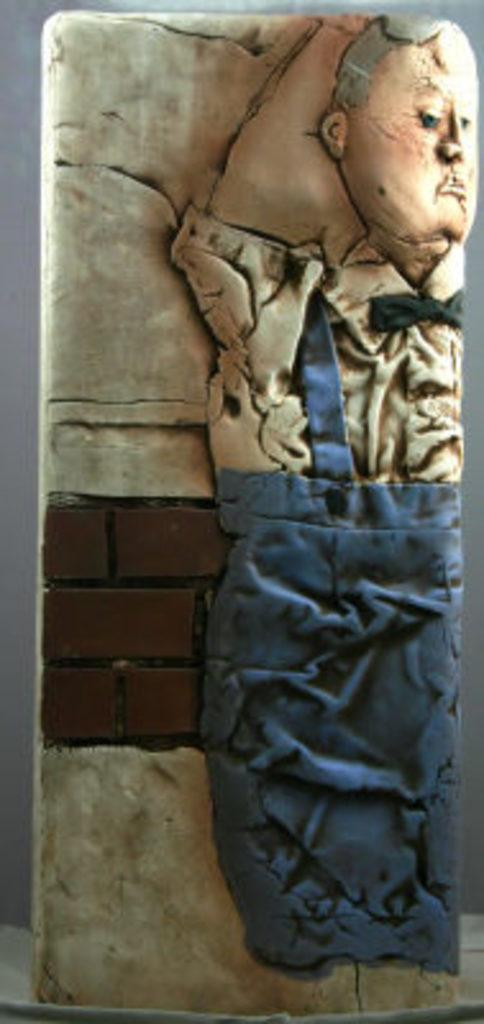What is the main subject of the image? There is a sculpture in the image. What material is the sculpture made of? The sculpture is carved on a stone. Are there any additional features on the sculpture? Yes, there are colors on the sculpture. What is the purpose of the horn in the image? There is no horn present in the image. The image features a sculpture made of stone with colors on it. 